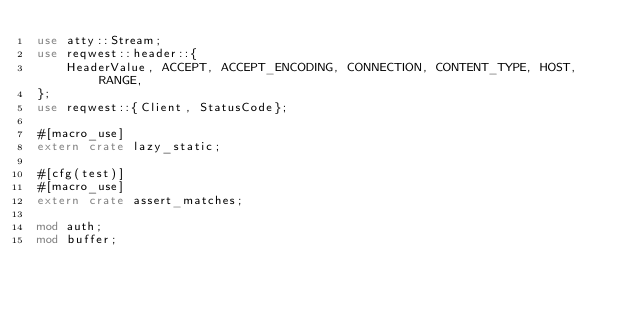Convert code to text. <code><loc_0><loc_0><loc_500><loc_500><_Rust_>use atty::Stream;
use reqwest::header::{
    HeaderValue, ACCEPT, ACCEPT_ENCODING, CONNECTION, CONTENT_TYPE, HOST, RANGE,
};
use reqwest::{Client, StatusCode};

#[macro_use]
extern crate lazy_static;

#[cfg(test)]
#[macro_use]
extern crate assert_matches;

mod auth;
mod buffer;</code> 